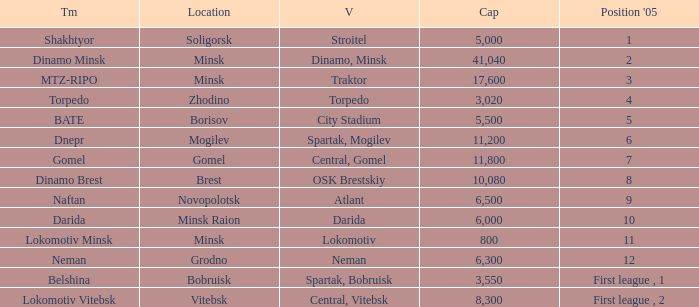Can you tell me the Capacity that has the Position in 2005 of 8? 10080.0. 